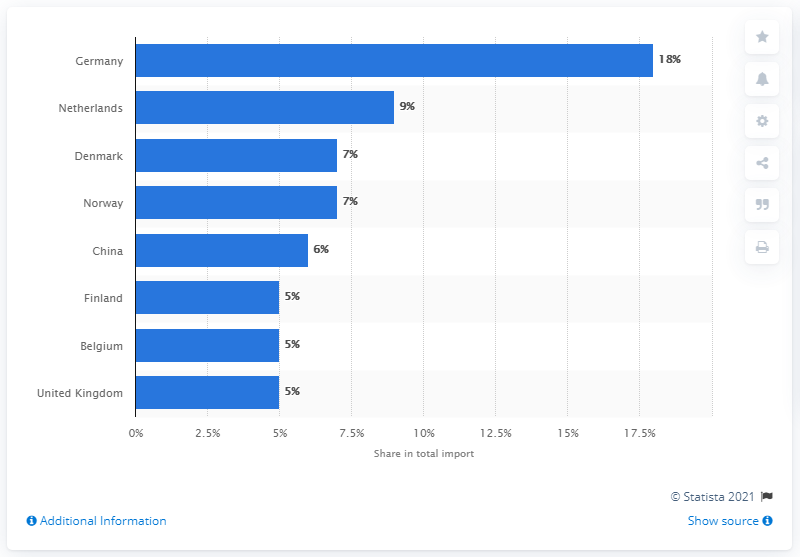Highlight a few significant elements in this photo. In 2019, Germany was Sweden's most important import partner. 